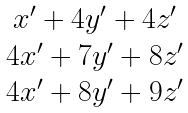<formula> <loc_0><loc_0><loc_500><loc_500>\begin{matrix} x ^ { \prime } + 4 y ^ { \prime } + 4 z ^ { \prime } \\ 4 x ^ { \prime } + 7 y ^ { \prime } + 8 z ^ { \prime } \\ 4 x ^ { \prime } + 8 y ^ { \prime } + 9 z ^ { \prime } \end{matrix}</formula> 